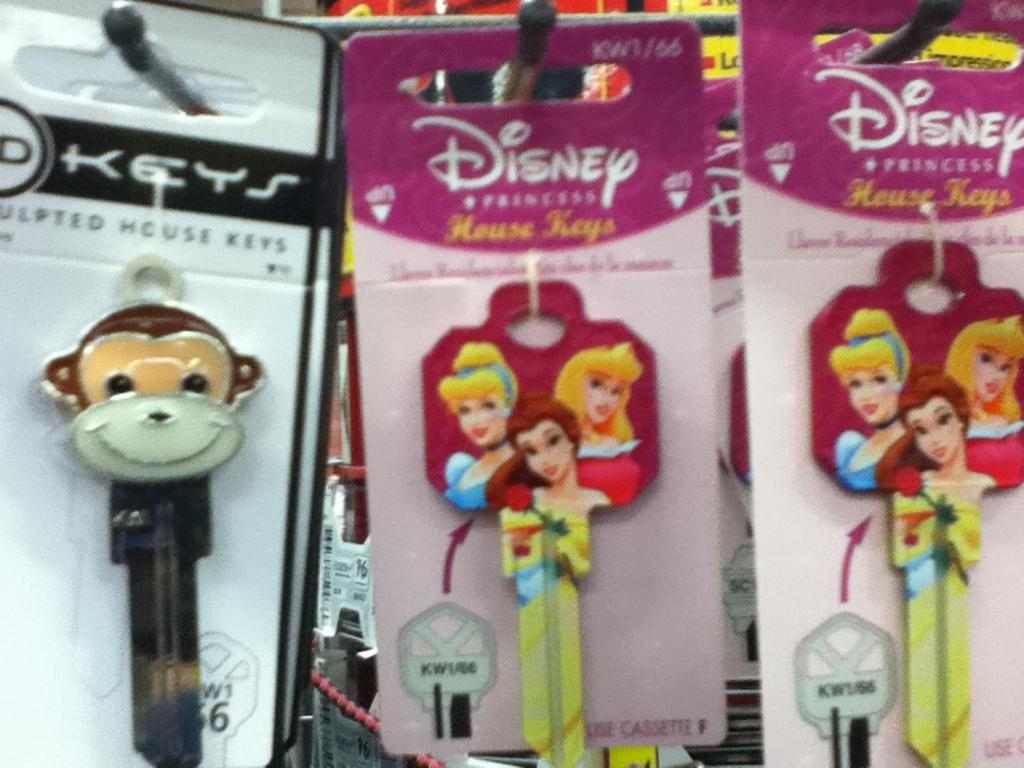What type of item is featured in the image? The image contains house key packs. How many sticks are included in each house key pack in the image? There is no mention of sticks in the image; it features house key packs. What type of creature is holding the house key packs in the image? There is no creature present in the image, as it only features house key packs. 